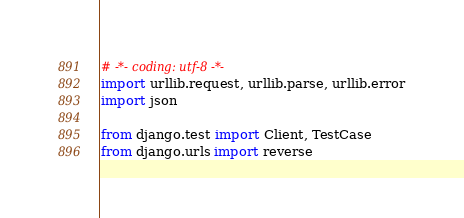<code> <loc_0><loc_0><loc_500><loc_500><_Python_># -*- coding: utf-8 -*-
import urllib.request, urllib.parse, urllib.error
import json

from django.test import Client, TestCase
from django.urls import reverse</code> 